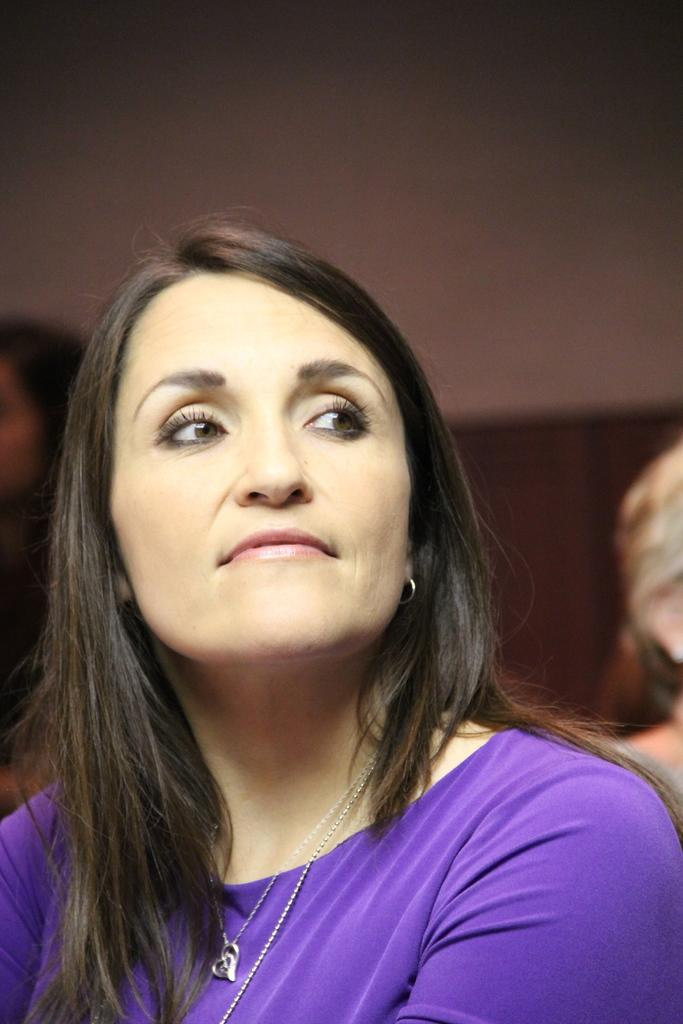What is the main subject in the foreground of the picture? There is a person in the foreground of the picture. What is the person wearing? The person is wearing a blue dress. What is the person's position in the picture? The person appears to be sitting. What can be seen in the background of the picture? There are other objects visible in the background of the picture. What type of leaf is being used as a symbol of belief in the image? There is no leaf or symbol of belief present in the image. 